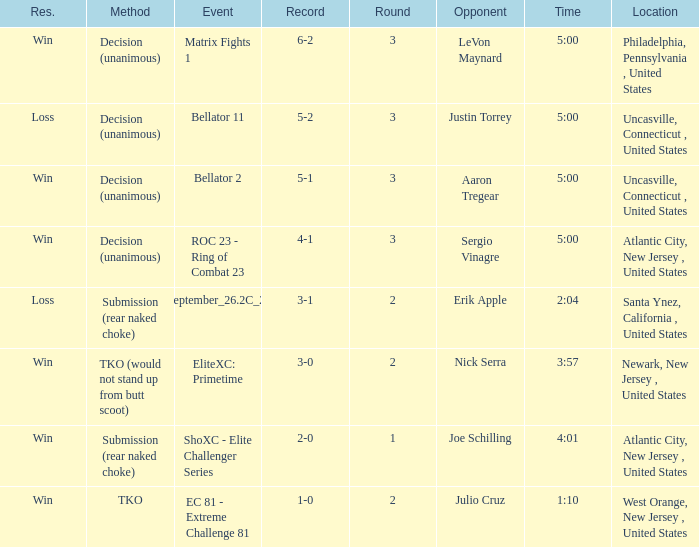What round was it when the method was TKO (would not stand up from Butt Scoot)? 2.0. 